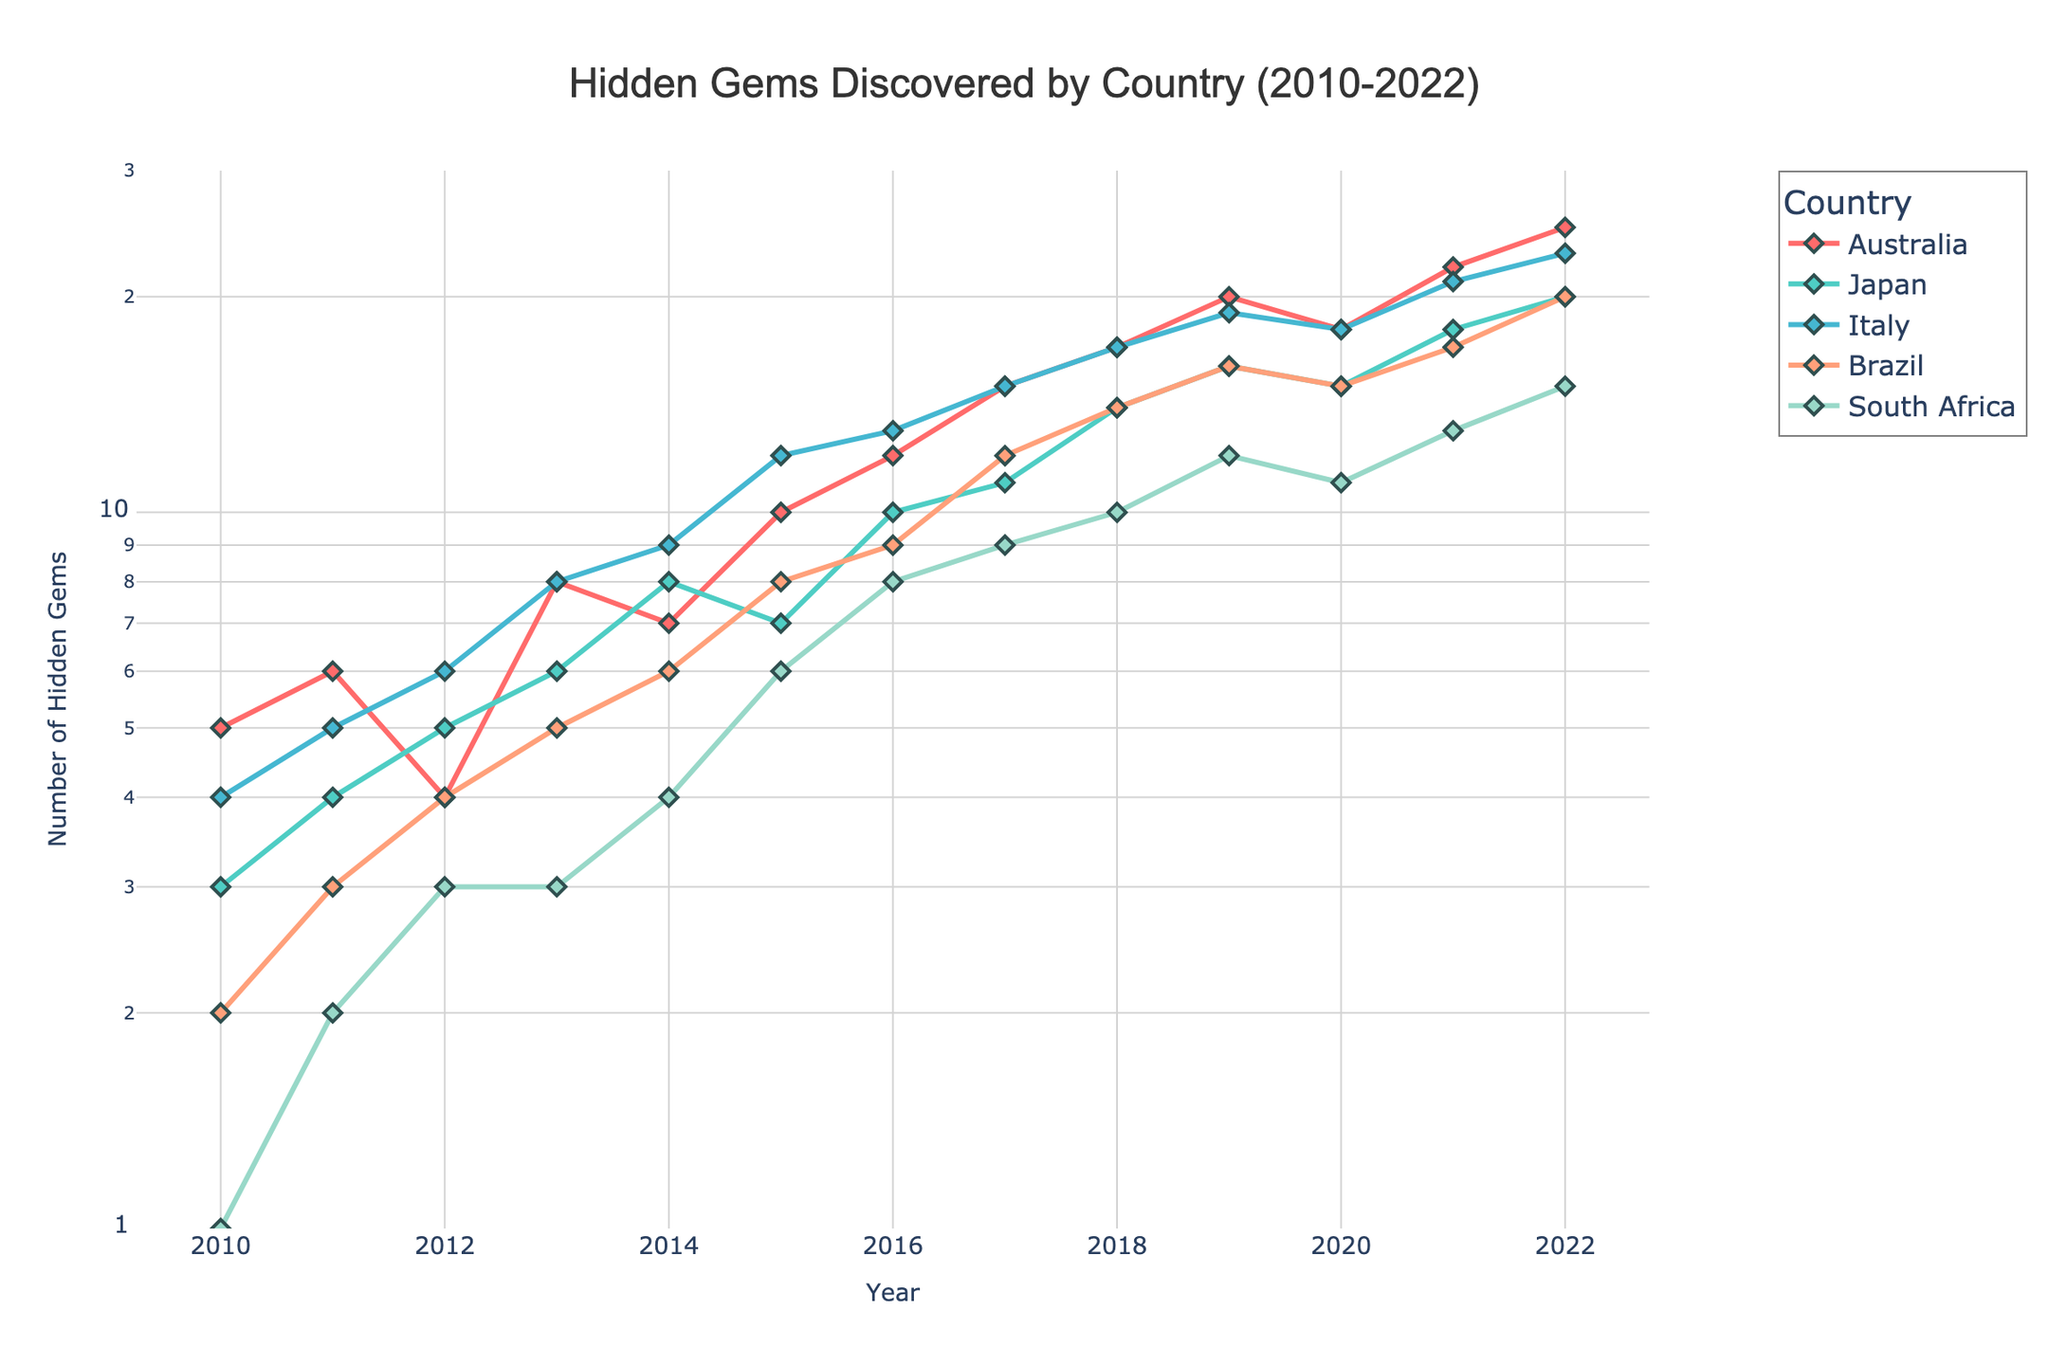What's the title of the figure? The title of the figure is located at the top center of the plot area. It reads "Hidden Gems Discovered by Country (2010-2022)."
Answer: Hidden Gems Discovered by Country (2010-2022) How many countries are represented in the plot? The legend on the right side of the figure includes a list of countries. By counting the entries, you can see there are five countries represented.
Answer: 5 What is the y-axis scale and what range does it cover? The y-axis is labeled "Number of Hidden Gems" and is plotted on a logarithmic scale. It ranges from 1 (just over 0 on the log scale) to roughly 10^1.5 (30) as indicated by the ticks.
Answer: Logarithmic, 1 to 30 Which country had the highest number of hidden gems discovered in 2022? Look for the data point representing the year 2022 and identify the country with the highest y-value. The line with the highest data point in 2022 belongs to Australia.
Answer: Australia Which country showed the steepest increase in the number of hidden gems from 2010 to 2022? By examining the slopes of the lines from 2010 to 2022, the steepest increase belongs to the country with the most upward trajectory. South Africa has the steepest increase as it starts very low and rises significantly.
Answer: South Africa How did the number of hidden gems discovered in Japan change from 2015 to 2016? Trace the line for Japan between the years 2015 and 2016. The y-value increases from 7 hidden gems in 2015 to 10 hidden gems in 2016, showing an increase.
Answer: Increased Compare the hidden gems discovered in Brazil in 2010 and 2022. By how much did it increase? Identify the y-values for Brazil in the years 2010 and 2022. The hidden gems discovered increased from 2 in 2010 to 20 in 2022. The difference is 20 - 2 = 18.
Answer: Increased by 18 Which country had a consistent increase in the number of hidden gems discovered every year? Analyze the trends for each country. The line that shows a consistent upward trend without any decline or plateau belongs to Italy.
Answer: Italy During which year did Australia have the largest single year-over-year increase in the number of hidden gems discovered? Examine the yearly differences for Australia. The largest increase occurred between 2015 (10 gems) and 2016 (12 gems). The increase is 12 - 10 = 2 gems.
Answer: 2016 What is the average number of hidden gems discovered by South Africa from 2010 to 2022? Sum up the number of hidden gems discovered in South Africa from 2010 to 2022 and divide by the number of years (13). (1+2+3+3+4+6+8+9+10+12+11+13+15) / 13 = 7.615.
Answer: 7.615 